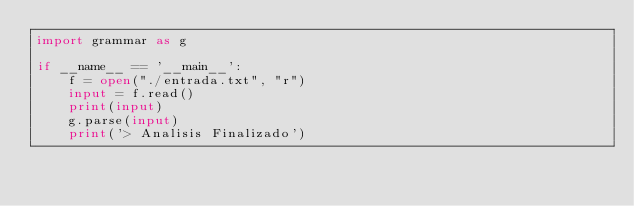Convert code to text. <code><loc_0><loc_0><loc_500><loc_500><_Python_>import grammar as g

if __name__ == '__main__':
    f = open("./entrada.txt", "r")
    input = f.read()
    print(input)
    g.parse(input)
    print('> Analisis Finalizado')


</code> 